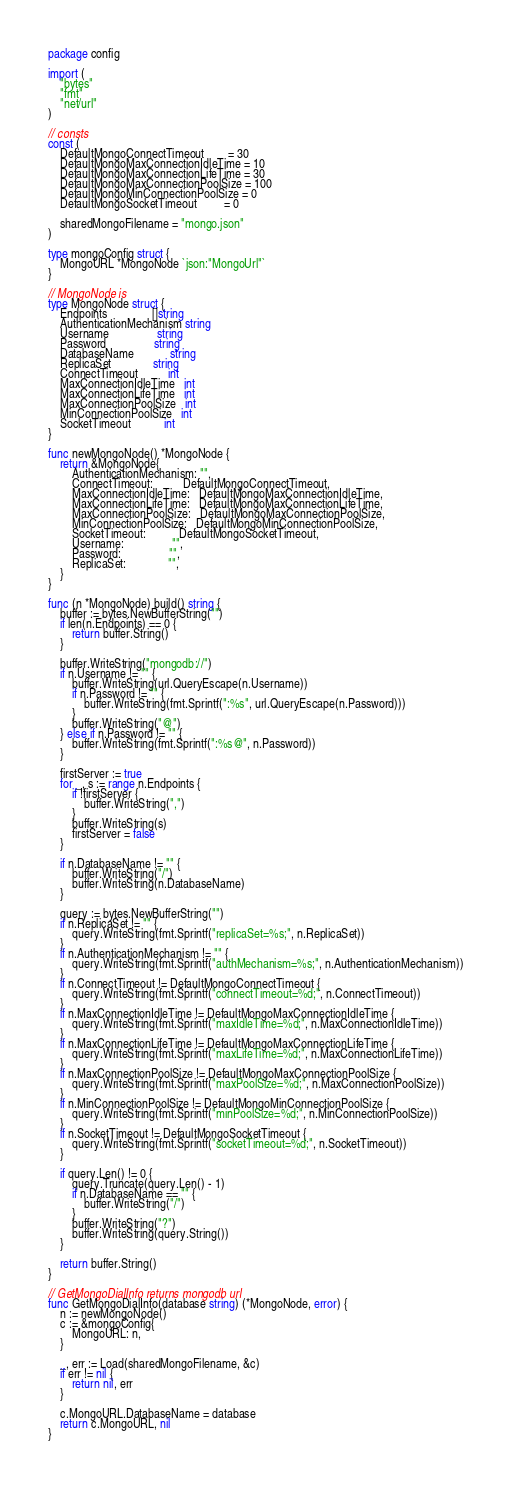Convert code to text. <code><loc_0><loc_0><loc_500><loc_500><_Go_>package config

import (
	"bytes"
	"fmt"
	"net/url"
)

// consts
const (
	DefaultMongoConnectTimeout        = 30
	DefaultMongoMaxConnectionIdleTime = 10
	DefaultMongoMaxConnectionLifeTime = 30
	DefaultMongoMaxConnectionPoolSize = 100
	DefaultMongoMinConnectionPoolSize = 0
	DefaultMongoSocketTimeout         = 0

	sharedMongoFilename = "mongo.json"
)

type mongoConfig struct {
	MongoURL *MongoNode `json:"MongoUrl"`
}

// MongoNode is
type MongoNode struct {
	Endpoints               []string
	AuthenticationMechanism string
	Username                string
	Password                string
	DatabaseName            string
	ReplicaSet              string
	ConnectTimeout          int
	MaxConnectionIdleTime   int
	MaxConnectionLifeTime   int
	MaxConnectionPoolSize   int
	MinConnectionPoolSize   int
	SocketTimeout           int
}

func newMongoNode() *MongoNode {
	return &MongoNode{
		AuthenticationMechanism: "",
		ConnectTimeout:          DefaultMongoConnectTimeout,
		MaxConnectionIdleTime:   DefaultMongoMaxConnectionIdleTime,
		MaxConnectionLifeTime:   DefaultMongoMaxConnectionLifeTime,
		MaxConnectionPoolSize:   DefaultMongoMaxConnectionPoolSize,
		MinConnectionPoolSize:   DefaultMongoMinConnectionPoolSize,
		SocketTimeout:           DefaultMongoSocketTimeout,
		Username:                "",
		Password:                "",
		ReplicaSet:              "",
	}
}

func (n *MongoNode) build() string {
	buffer := bytes.NewBufferString("")
	if len(n.Endpoints) == 0 {
		return buffer.String()
	}

	buffer.WriteString("mongodb://")
	if n.Username != "" {
		buffer.WriteString(url.QueryEscape(n.Username))
		if n.Password != "" {
			buffer.WriteString(fmt.Sprintf(":%s", url.QueryEscape(n.Password)))
		}
		buffer.WriteString("@")
	} else if n.Password != "" {
		buffer.WriteString(fmt.Sprintf(":%s@", n.Password))
	}

	firstServer := true
	for _, s := range n.Endpoints {
		if !firstServer {
			buffer.WriteString(",")
		}
		buffer.WriteString(s)
		firstServer = false
	}

	if n.DatabaseName != "" {
		buffer.WriteString("/")
		buffer.WriteString(n.DatabaseName)
	}

	query := bytes.NewBufferString("")
	if n.ReplicaSet != "" {
		query.WriteString(fmt.Sprintf("replicaSet=%s;", n.ReplicaSet))
	}
	if n.AuthenticationMechanism != "" {
		query.WriteString(fmt.Sprintf("authMechanism=%s;", n.AuthenticationMechanism))
	}
	if n.ConnectTimeout != DefaultMongoConnectTimeout {
		query.WriteString(fmt.Sprintf("connectTimeout=%d;", n.ConnectTimeout))
	}
	if n.MaxConnectionIdleTime != DefaultMongoMaxConnectionIdleTime {
		query.WriteString(fmt.Sprintf("maxIdleTime=%d;", n.MaxConnectionIdleTime))
	}
	if n.MaxConnectionLifeTime != DefaultMongoMaxConnectionLifeTime {
		query.WriteString(fmt.Sprintf("maxLifeTime=%d;", n.MaxConnectionLifeTime))
	}
	if n.MaxConnectionPoolSize != DefaultMongoMaxConnectionPoolSize {
		query.WriteString(fmt.Sprintf("maxPoolSize=%d;", n.MaxConnectionPoolSize))
	}
	if n.MinConnectionPoolSize != DefaultMongoMinConnectionPoolSize {
		query.WriteString(fmt.Sprintf("minPoolSize=%d;", n.MinConnectionPoolSize))
	}
	if n.SocketTimeout != DefaultMongoSocketTimeout {
		query.WriteString(fmt.Sprintf("socketTimeout=%d;", n.SocketTimeout))
	}

	if query.Len() != 0 {
		query.Truncate(query.Len() - 1)
		if n.DatabaseName == "" {
			buffer.WriteString("/")
		}
		buffer.WriteString("?")
		buffer.WriteString(query.String())
	}

	return buffer.String()
}

// GetMongoDialInfo returns mongodb url
func GetMongoDialInfo(database string) (*MongoNode, error) {
	n := newMongoNode()
	c := &mongoConfig{
		MongoURL: n,
	}

	_, err := Load(sharedMongoFilename, &c)
	if err != nil {
		return nil, err
	}

	c.MongoURL.DatabaseName = database
	return c.MongoURL, nil
}
</code> 